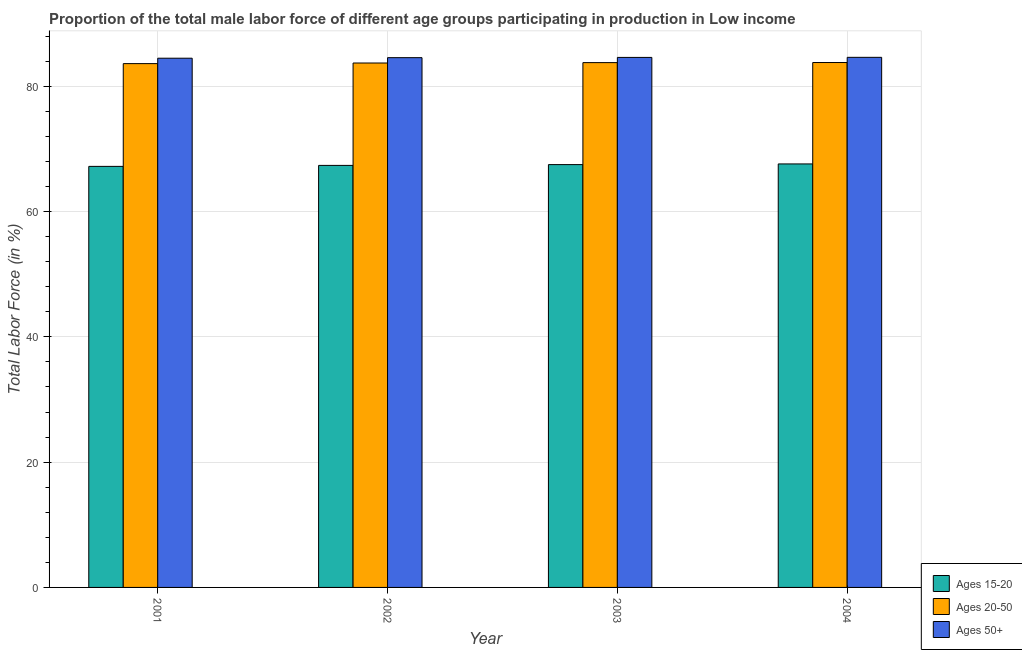How many different coloured bars are there?
Your response must be concise. 3. How many groups of bars are there?
Offer a terse response. 4. In how many cases, is the number of bars for a given year not equal to the number of legend labels?
Ensure brevity in your answer.  0. What is the percentage of male labor force within the age group 20-50 in 2002?
Provide a succinct answer. 83.71. Across all years, what is the maximum percentage of male labor force above age 50?
Offer a very short reply. 84.62. Across all years, what is the minimum percentage of male labor force above age 50?
Give a very brief answer. 84.48. What is the total percentage of male labor force within the age group 20-50 in the graph?
Offer a terse response. 334.9. What is the difference between the percentage of male labor force within the age group 15-20 in 2002 and that in 2004?
Your answer should be compact. -0.23. What is the difference between the percentage of male labor force within the age group 20-50 in 2001 and the percentage of male labor force within the age group 15-20 in 2004?
Offer a terse response. -0.17. What is the average percentage of male labor force within the age group 15-20 per year?
Keep it short and to the point. 67.42. What is the ratio of the percentage of male labor force within the age group 15-20 in 2001 to that in 2004?
Keep it short and to the point. 0.99. What is the difference between the highest and the second highest percentage of male labor force above age 50?
Ensure brevity in your answer.  0.01. What is the difference between the highest and the lowest percentage of male labor force within the age group 20-50?
Give a very brief answer. 0.17. Is the sum of the percentage of male labor force above age 50 in 2002 and 2004 greater than the maximum percentage of male labor force within the age group 20-50 across all years?
Provide a short and direct response. Yes. What does the 2nd bar from the left in 2001 represents?
Your response must be concise. Ages 20-50. What does the 2nd bar from the right in 2001 represents?
Ensure brevity in your answer.  Ages 20-50. How many years are there in the graph?
Provide a short and direct response. 4. Are the values on the major ticks of Y-axis written in scientific E-notation?
Provide a short and direct response. No. Does the graph contain grids?
Your answer should be compact. Yes. Where does the legend appear in the graph?
Provide a succinct answer. Bottom right. How are the legend labels stacked?
Make the answer very short. Vertical. What is the title of the graph?
Ensure brevity in your answer.  Proportion of the total male labor force of different age groups participating in production in Low income. Does "Female employers" appear as one of the legend labels in the graph?
Your answer should be compact. No. What is the label or title of the Y-axis?
Keep it short and to the point. Total Labor Force (in %). What is the Total Labor Force (in %) of Ages 15-20 in 2001?
Offer a terse response. 67.21. What is the Total Labor Force (in %) of Ages 20-50 in 2001?
Make the answer very short. 83.62. What is the Total Labor Force (in %) of Ages 50+ in 2001?
Offer a terse response. 84.48. What is the Total Labor Force (in %) in Ages 15-20 in 2002?
Provide a succinct answer. 67.37. What is the Total Labor Force (in %) in Ages 20-50 in 2002?
Offer a very short reply. 83.71. What is the Total Labor Force (in %) in Ages 50+ in 2002?
Your response must be concise. 84.57. What is the Total Labor Force (in %) in Ages 15-20 in 2003?
Your answer should be compact. 67.5. What is the Total Labor Force (in %) of Ages 20-50 in 2003?
Ensure brevity in your answer.  83.78. What is the Total Labor Force (in %) of Ages 50+ in 2003?
Your response must be concise. 84.61. What is the Total Labor Force (in %) of Ages 15-20 in 2004?
Your answer should be very brief. 67.6. What is the Total Labor Force (in %) in Ages 20-50 in 2004?
Make the answer very short. 83.79. What is the Total Labor Force (in %) of Ages 50+ in 2004?
Ensure brevity in your answer.  84.62. Across all years, what is the maximum Total Labor Force (in %) in Ages 15-20?
Ensure brevity in your answer.  67.6. Across all years, what is the maximum Total Labor Force (in %) in Ages 20-50?
Your response must be concise. 83.79. Across all years, what is the maximum Total Labor Force (in %) of Ages 50+?
Keep it short and to the point. 84.62. Across all years, what is the minimum Total Labor Force (in %) of Ages 15-20?
Your response must be concise. 67.21. Across all years, what is the minimum Total Labor Force (in %) of Ages 20-50?
Give a very brief answer. 83.62. Across all years, what is the minimum Total Labor Force (in %) in Ages 50+?
Your answer should be very brief. 84.48. What is the total Total Labor Force (in %) in Ages 15-20 in the graph?
Provide a succinct answer. 269.68. What is the total Total Labor Force (in %) in Ages 20-50 in the graph?
Give a very brief answer. 334.9. What is the total Total Labor Force (in %) of Ages 50+ in the graph?
Provide a succinct answer. 338.27. What is the difference between the Total Labor Force (in %) of Ages 15-20 in 2001 and that in 2002?
Offer a very short reply. -0.16. What is the difference between the Total Labor Force (in %) of Ages 20-50 in 2001 and that in 2002?
Provide a succinct answer. -0.1. What is the difference between the Total Labor Force (in %) in Ages 50+ in 2001 and that in 2002?
Offer a very short reply. -0.09. What is the difference between the Total Labor Force (in %) of Ages 15-20 in 2001 and that in 2003?
Provide a succinct answer. -0.28. What is the difference between the Total Labor Force (in %) in Ages 20-50 in 2001 and that in 2003?
Provide a succinct answer. -0.16. What is the difference between the Total Labor Force (in %) of Ages 50+ in 2001 and that in 2003?
Your answer should be very brief. -0.13. What is the difference between the Total Labor Force (in %) in Ages 15-20 in 2001 and that in 2004?
Keep it short and to the point. -0.39. What is the difference between the Total Labor Force (in %) of Ages 20-50 in 2001 and that in 2004?
Your response must be concise. -0.17. What is the difference between the Total Labor Force (in %) in Ages 50+ in 2001 and that in 2004?
Provide a succinct answer. -0.14. What is the difference between the Total Labor Force (in %) in Ages 15-20 in 2002 and that in 2003?
Keep it short and to the point. -0.13. What is the difference between the Total Labor Force (in %) of Ages 20-50 in 2002 and that in 2003?
Provide a short and direct response. -0.06. What is the difference between the Total Labor Force (in %) in Ages 50+ in 2002 and that in 2003?
Offer a terse response. -0.04. What is the difference between the Total Labor Force (in %) in Ages 15-20 in 2002 and that in 2004?
Your answer should be very brief. -0.23. What is the difference between the Total Labor Force (in %) in Ages 20-50 in 2002 and that in 2004?
Ensure brevity in your answer.  -0.08. What is the difference between the Total Labor Force (in %) in Ages 50+ in 2002 and that in 2004?
Provide a short and direct response. -0.05. What is the difference between the Total Labor Force (in %) of Ages 15-20 in 2003 and that in 2004?
Give a very brief answer. -0.11. What is the difference between the Total Labor Force (in %) of Ages 20-50 in 2003 and that in 2004?
Your answer should be compact. -0.01. What is the difference between the Total Labor Force (in %) in Ages 50+ in 2003 and that in 2004?
Your answer should be very brief. -0.01. What is the difference between the Total Labor Force (in %) in Ages 15-20 in 2001 and the Total Labor Force (in %) in Ages 20-50 in 2002?
Keep it short and to the point. -16.5. What is the difference between the Total Labor Force (in %) of Ages 15-20 in 2001 and the Total Labor Force (in %) of Ages 50+ in 2002?
Your answer should be very brief. -17.35. What is the difference between the Total Labor Force (in %) of Ages 20-50 in 2001 and the Total Labor Force (in %) of Ages 50+ in 2002?
Keep it short and to the point. -0.95. What is the difference between the Total Labor Force (in %) of Ages 15-20 in 2001 and the Total Labor Force (in %) of Ages 20-50 in 2003?
Provide a short and direct response. -16.56. What is the difference between the Total Labor Force (in %) in Ages 15-20 in 2001 and the Total Labor Force (in %) in Ages 50+ in 2003?
Your answer should be compact. -17.4. What is the difference between the Total Labor Force (in %) of Ages 20-50 in 2001 and the Total Labor Force (in %) of Ages 50+ in 2003?
Ensure brevity in your answer.  -0.99. What is the difference between the Total Labor Force (in %) in Ages 15-20 in 2001 and the Total Labor Force (in %) in Ages 20-50 in 2004?
Provide a succinct answer. -16.58. What is the difference between the Total Labor Force (in %) in Ages 15-20 in 2001 and the Total Labor Force (in %) in Ages 50+ in 2004?
Keep it short and to the point. -17.41. What is the difference between the Total Labor Force (in %) of Ages 20-50 in 2001 and the Total Labor Force (in %) of Ages 50+ in 2004?
Provide a short and direct response. -1. What is the difference between the Total Labor Force (in %) in Ages 15-20 in 2002 and the Total Labor Force (in %) in Ages 20-50 in 2003?
Your response must be concise. -16.41. What is the difference between the Total Labor Force (in %) of Ages 15-20 in 2002 and the Total Labor Force (in %) of Ages 50+ in 2003?
Offer a terse response. -17.24. What is the difference between the Total Labor Force (in %) of Ages 20-50 in 2002 and the Total Labor Force (in %) of Ages 50+ in 2003?
Make the answer very short. -0.89. What is the difference between the Total Labor Force (in %) of Ages 15-20 in 2002 and the Total Labor Force (in %) of Ages 20-50 in 2004?
Provide a succinct answer. -16.42. What is the difference between the Total Labor Force (in %) in Ages 15-20 in 2002 and the Total Labor Force (in %) in Ages 50+ in 2004?
Make the answer very short. -17.25. What is the difference between the Total Labor Force (in %) in Ages 20-50 in 2002 and the Total Labor Force (in %) in Ages 50+ in 2004?
Your response must be concise. -0.91. What is the difference between the Total Labor Force (in %) of Ages 15-20 in 2003 and the Total Labor Force (in %) of Ages 20-50 in 2004?
Offer a very short reply. -16.29. What is the difference between the Total Labor Force (in %) of Ages 15-20 in 2003 and the Total Labor Force (in %) of Ages 50+ in 2004?
Give a very brief answer. -17.12. What is the difference between the Total Labor Force (in %) in Ages 20-50 in 2003 and the Total Labor Force (in %) in Ages 50+ in 2004?
Offer a very short reply. -0.84. What is the average Total Labor Force (in %) in Ages 15-20 per year?
Ensure brevity in your answer.  67.42. What is the average Total Labor Force (in %) of Ages 20-50 per year?
Ensure brevity in your answer.  83.72. What is the average Total Labor Force (in %) in Ages 50+ per year?
Ensure brevity in your answer.  84.57. In the year 2001, what is the difference between the Total Labor Force (in %) in Ages 15-20 and Total Labor Force (in %) in Ages 20-50?
Offer a very short reply. -16.41. In the year 2001, what is the difference between the Total Labor Force (in %) of Ages 15-20 and Total Labor Force (in %) of Ages 50+?
Your response must be concise. -17.27. In the year 2001, what is the difference between the Total Labor Force (in %) in Ages 20-50 and Total Labor Force (in %) in Ages 50+?
Keep it short and to the point. -0.86. In the year 2002, what is the difference between the Total Labor Force (in %) of Ages 15-20 and Total Labor Force (in %) of Ages 20-50?
Provide a succinct answer. -16.34. In the year 2002, what is the difference between the Total Labor Force (in %) of Ages 15-20 and Total Labor Force (in %) of Ages 50+?
Provide a short and direct response. -17.2. In the year 2002, what is the difference between the Total Labor Force (in %) in Ages 20-50 and Total Labor Force (in %) in Ages 50+?
Provide a short and direct response. -0.85. In the year 2003, what is the difference between the Total Labor Force (in %) in Ages 15-20 and Total Labor Force (in %) in Ages 20-50?
Offer a terse response. -16.28. In the year 2003, what is the difference between the Total Labor Force (in %) in Ages 15-20 and Total Labor Force (in %) in Ages 50+?
Ensure brevity in your answer.  -17.11. In the year 2003, what is the difference between the Total Labor Force (in %) in Ages 20-50 and Total Labor Force (in %) in Ages 50+?
Your answer should be very brief. -0.83. In the year 2004, what is the difference between the Total Labor Force (in %) of Ages 15-20 and Total Labor Force (in %) of Ages 20-50?
Your response must be concise. -16.19. In the year 2004, what is the difference between the Total Labor Force (in %) in Ages 15-20 and Total Labor Force (in %) in Ages 50+?
Make the answer very short. -17.02. In the year 2004, what is the difference between the Total Labor Force (in %) of Ages 20-50 and Total Labor Force (in %) of Ages 50+?
Make the answer very short. -0.83. What is the ratio of the Total Labor Force (in %) in Ages 15-20 in 2001 to that in 2002?
Make the answer very short. 1. What is the ratio of the Total Labor Force (in %) in Ages 20-50 in 2001 to that in 2002?
Offer a very short reply. 1. What is the ratio of the Total Labor Force (in %) in Ages 15-20 in 2001 to that in 2003?
Your answer should be compact. 1. What is the ratio of the Total Labor Force (in %) of Ages 50+ in 2001 to that in 2003?
Your response must be concise. 1. What is the ratio of the Total Labor Force (in %) in Ages 15-20 in 2001 to that in 2004?
Offer a very short reply. 0.99. What is the ratio of the Total Labor Force (in %) in Ages 20-50 in 2001 to that in 2004?
Give a very brief answer. 1. What is the ratio of the Total Labor Force (in %) in Ages 50+ in 2001 to that in 2004?
Make the answer very short. 1. What is the ratio of the Total Labor Force (in %) of Ages 50+ in 2002 to that in 2003?
Your answer should be very brief. 1. What is the ratio of the Total Labor Force (in %) in Ages 15-20 in 2002 to that in 2004?
Your answer should be compact. 1. What is the ratio of the Total Labor Force (in %) in Ages 15-20 in 2003 to that in 2004?
Your answer should be very brief. 1. What is the difference between the highest and the second highest Total Labor Force (in %) of Ages 15-20?
Your response must be concise. 0.11. What is the difference between the highest and the second highest Total Labor Force (in %) in Ages 20-50?
Your answer should be very brief. 0.01. What is the difference between the highest and the second highest Total Labor Force (in %) in Ages 50+?
Provide a succinct answer. 0.01. What is the difference between the highest and the lowest Total Labor Force (in %) of Ages 15-20?
Provide a succinct answer. 0.39. What is the difference between the highest and the lowest Total Labor Force (in %) of Ages 20-50?
Provide a short and direct response. 0.17. What is the difference between the highest and the lowest Total Labor Force (in %) in Ages 50+?
Your response must be concise. 0.14. 